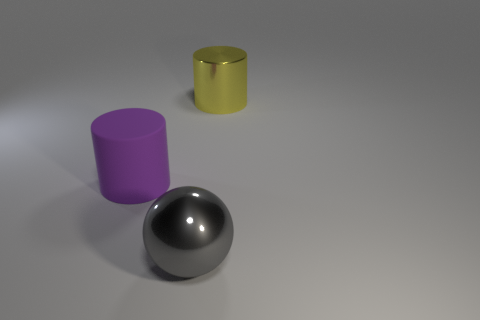There is a metallic thing right of the gray metal object; does it have the same shape as the gray metal thing?
Provide a short and direct response. No. Are there more large yellow metal objects in front of the large yellow object than small gray blocks?
Your response must be concise. No. What is the large thing that is behind the big gray metallic ball and on the left side of the yellow metal cylinder made of?
Provide a succinct answer. Rubber. Is there anything else that has the same shape as the large purple thing?
Your answer should be compact. Yes. What number of big things are both on the left side of the metallic cylinder and behind the shiny ball?
Your answer should be compact. 1. What material is the ball?
Give a very brief answer. Metal. Is the number of large purple matte cylinders on the right side of the big purple thing the same as the number of gray objects?
Provide a succinct answer. No. How many other purple matte things have the same shape as the large purple thing?
Provide a short and direct response. 0. Is the shape of the big yellow metallic thing the same as the purple object?
Your answer should be compact. Yes. How many things are large cylinders right of the large purple thing or small red blocks?
Give a very brief answer. 1. 